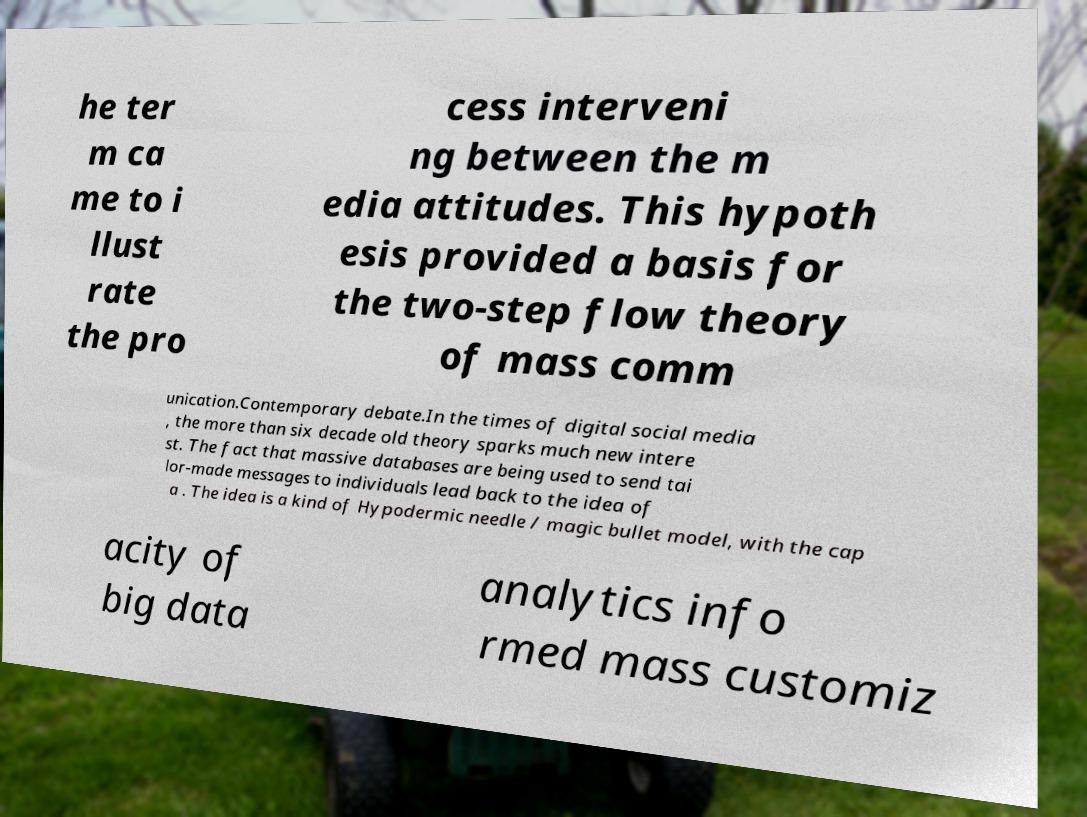What messages or text are displayed in this image? I need them in a readable, typed format. he ter m ca me to i llust rate the pro cess interveni ng between the m edia attitudes. This hypoth esis provided a basis for the two-step flow theory of mass comm unication.Contemporary debate.In the times of digital social media , the more than six decade old theory sparks much new intere st. The fact that massive databases are being used to send tai lor-made messages to individuals lead back to the idea of a . The idea is a kind of Hypodermic needle / magic bullet model, with the cap acity of big data analytics info rmed mass customiz 